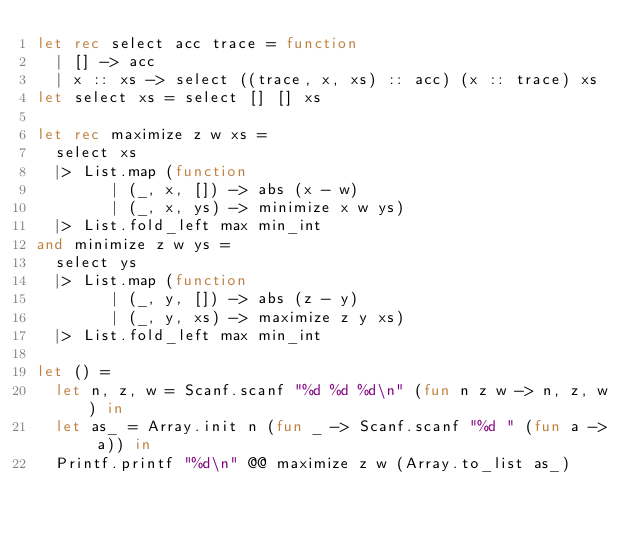Convert code to text. <code><loc_0><loc_0><loc_500><loc_500><_OCaml_>let rec select acc trace = function
  | [] -> acc
  | x :: xs -> select ((trace, x, xs) :: acc) (x :: trace) xs
let select xs = select [] [] xs

let rec maximize z w xs =
  select xs
  |> List.map (function
        | (_, x, []) -> abs (x - w)
        | (_, x, ys) -> minimize x w ys)
  |> List.fold_left max min_int
and minimize z w ys = 
  select ys
  |> List.map (function
        | (_, y, []) -> abs (z - y)
        | (_, y, xs) -> maximize z y xs)
  |> List.fold_left max min_int

let () =
  let n, z, w = Scanf.scanf "%d %d %d\n" (fun n z w -> n, z, w) in
  let as_ = Array.init n (fun _ -> Scanf.scanf "%d " (fun a -> a)) in
  Printf.printf "%d\n" @@ maximize z w (Array.to_list as_)</code> 